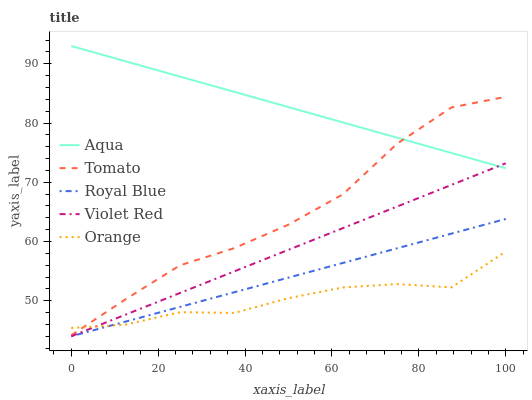Does Orange have the minimum area under the curve?
Answer yes or no. Yes. Does Aqua have the maximum area under the curve?
Answer yes or no. Yes. Does Royal Blue have the minimum area under the curve?
Answer yes or no. No. Does Royal Blue have the maximum area under the curve?
Answer yes or no. No. Is Aqua the smoothest?
Answer yes or no. Yes. Is Orange the roughest?
Answer yes or no. Yes. Is Royal Blue the smoothest?
Answer yes or no. No. Is Royal Blue the roughest?
Answer yes or no. No. Does Aqua have the lowest value?
Answer yes or no. No. Does Aqua have the highest value?
Answer yes or no. Yes. Does Royal Blue have the highest value?
Answer yes or no. No. Is Royal Blue less than Aqua?
Answer yes or no. Yes. Is Aqua greater than Royal Blue?
Answer yes or no. Yes. Does Orange intersect Violet Red?
Answer yes or no. Yes. Is Orange less than Violet Red?
Answer yes or no. No. Is Orange greater than Violet Red?
Answer yes or no. No. Does Royal Blue intersect Aqua?
Answer yes or no. No. 